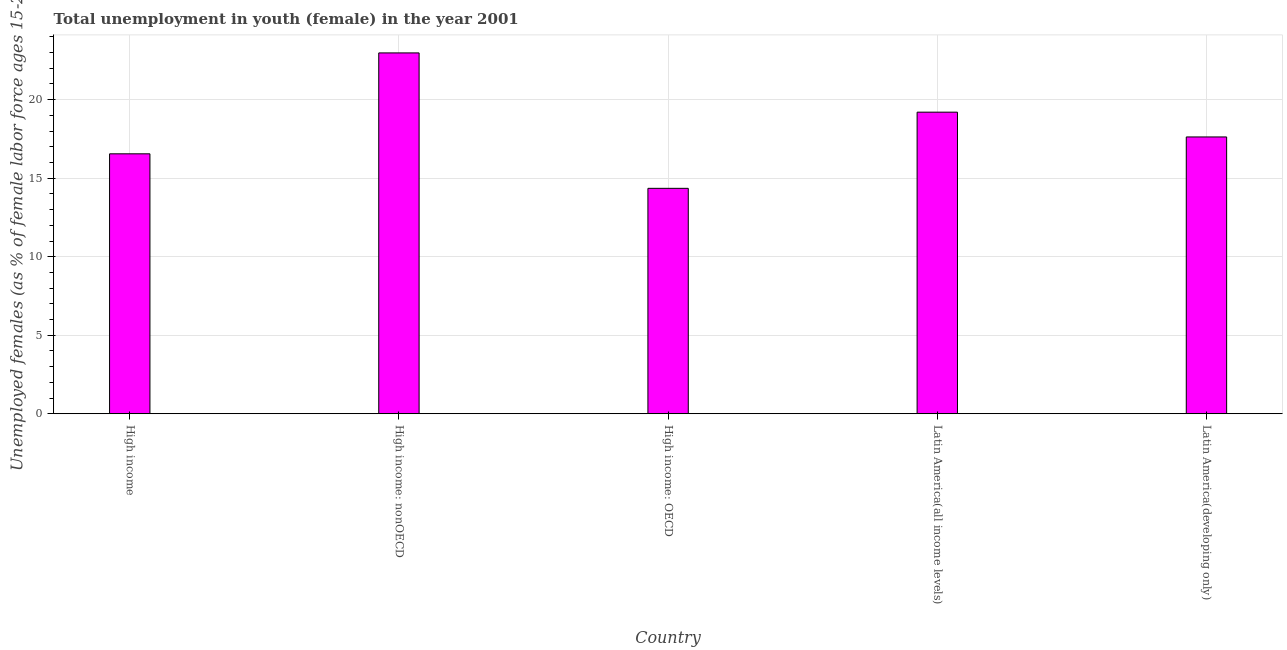Does the graph contain any zero values?
Give a very brief answer. No. Does the graph contain grids?
Ensure brevity in your answer.  Yes. What is the title of the graph?
Provide a short and direct response. Total unemployment in youth (female) in the year 2001. What is the label or title of the Y-axis?
Your answer should be very brief. Unemployed females (as % of female labor force ages 15-24). What is the unemployed female youth population in High income: nonOECD?
Offer a terse response. 22.98. Across all countries, what is the maximum unemployed female youth population?
Offer a terse response. 22.98. Across all countries, what is the minimum unemployed female youth population?
Give a very brief answer. 14.35. In which country was the unemployed female youth population maximum?
Provide a succinct answer. High income: nonOECD. In which country was the unemployed female youth population minimum?
Offer a terse response. High income: OECD. What is the sum of the unemployed female youth population?
Provide a short and direct response. 90.72. What is the difference between the unemployed female youth population in High income: nonOECD and Latin America(developing only)?
Offer a very short reply. 5.35. What is the average unemployed female youth population per country?
Give a very brief answer. 18.14. What is the median unemployed female youth population?
Give a very brief answer. 17.63. In how many countries, is the unemployed female youth population greater than 21 %?
Provide a short and direct response. 1. What is the ratio of the unemployed female youth population in High income to that in High income: nonOECD?
Provide a succinct answer. 0.72. Is the unemployed female youth population in High income: OECD less than that in Latin America(all income levels)?
Offer a very short reply. Yes. What is the difference between the highest and the second highest unemployed female youth population?
Provide a short and direct response. 3.77. What is the difference between the highest and the lowest unemployed female youth population?
Provide a short and direct response. 8.62. In how many countries, is the unemployed female youth population greater than the average unemployed female youth population taken over all countries?
Give a very brief answer. 2. How many bars are there?
Ensure brevity in your answer.  5. What is the difference between two consecutive major ticks on the Y-axis?
Your answer should be very brief. 5. What is the Unemployed females (as % of female labor force ages 15-24) of High income?
Your answer should be compact. 16.55. What is the Unemployed females (as % of female labor force ages 15-24) of High income: nonOECD?
Provide a short and direct response. 22.98. What is the Unemployed females (as % of female labor force ages 15-24) of High income: OECD?
Ensure brevity in your answer.  14.35. What is the Unemployed females (as % of female labor force ages 15-24) of Latin America(all income levels)?
Give a very brief answer. 19.21. What is the Unemployed females (as % of female labor force ages 15-24) of Latin America(developing only)?
Your response must be concise. 17.63. What is the difference between the Unemployed females (as % of female labor force ages 15-24) in High income and High income: nonOECD?
Provide a succinct answer. -6.43. What is the difference between the Unemployed females (as % of female labor force ages 15-24) in High income and High income: OECD?
Ensure brevity in your answer.  2.2. What is the difference between the Unemployed females (as % of female labor force ages 15-24) in High income and Latin America(all income levels)?
Offer a terse response. -2.65. What is the difference between the Unemployed females (as % of female labor force ages 15-24) in High income and Latin America(developing only)?
Give a very brief answer. -1.07. What is the difference between the Unemployed females (as % of female labor force ages 15-24) in High income: nonOECD and High income: OECD?
Offer a very short reply. 8.62. What is the difference between the Unemployed females (as % of female labor force ages 15-24) in High income: nonOECD and Latin America(all income levels)?
Make the answer very short. 3.77. What is the difference between the Unemployed females (as % of female labor force ages 15-24) in High income: nonOECD and Latin America(developing only)?
Your answer should be compact. 5.35. What is the difference between the Unemployed females (as % of female labor force ages 15-24) in High income: OECD and Latin America(all income levels)?
Offer a very short reply. -4.85. What is the difference between the Unemployed females (as % of female labor force ages 15-24) in High income: OECD and Latin America(developing only)?
Your answer should be very brief. -3.27. What is the difference between the Unemployed females (as % of female labor force ages 15-24) in Latin America(all income levels) and Latin America(developing only)?
Provide a succinct answer. 1.58. What is the ratio of the Unemployed females (as % of female labor force ages 15-24) in High income to that in High income: nonOECD?
Ensure brevity in your answer.  0.72. What is the ratio of the Unemployed females (as % of female labor force ages 15-24) in High income to that in High income: OECD?
Make the answer very short. 1.15. What is the ratio of the Unemployed females (as % of female labor force ages 15-24) in High income to that in Latin America(all income levels)?
Ensure brevity in your answer.  0.86. What is the ratio of the Unemployed females (as % of female labor force ages 15-24) in High income to that in Latin America(developing only)?
Ensure brevity in your answer.  0.94. What is the ratio of the Unemployed females (as % of female labor force ages 15-24) in High income: nonOECD to that in High income: OECD?
Your answer should be very brief. 1.6. What is the ratio of the Unemployed females (as % of female labor force ages 15-24) in High income: nonOECD to that in Latin America(all income levels)?
Give a very brief answer. 1.2. What is the ratio of the Unemployed females (as % of female labor force ages 15-24) in High income: nonOECD to that in Latin America(developing only)?
Offer a terse response. 1.3. What is the ratio of the Unemployed females (as % of female labor force ages 15-24) in High income: OECD to that in Latin America(all income levels)?
Make the answer very short. 0.75. What is the ratio of the Unemployed females (as % of female labor force ages 15-24) in High income: OECD to that in Latin America(developing only)?
Your answer should be compact. 0.81. What is the ratio of the Unemployed females (as % of female labor force ages 15-24) in Latin America(all income levels) to that in Latin America(developing only)?
Give a very brief answer. 1.09. 